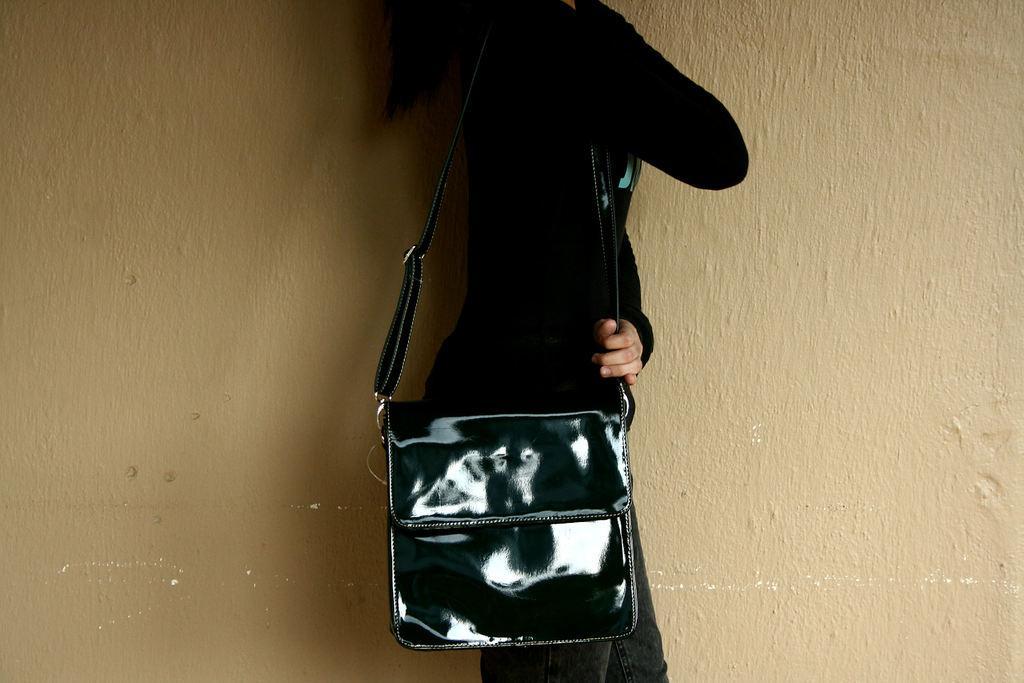Please provide a concise description of this image. In this picture we can see person wore black color jacket bag carrying and in background we can see wall. 